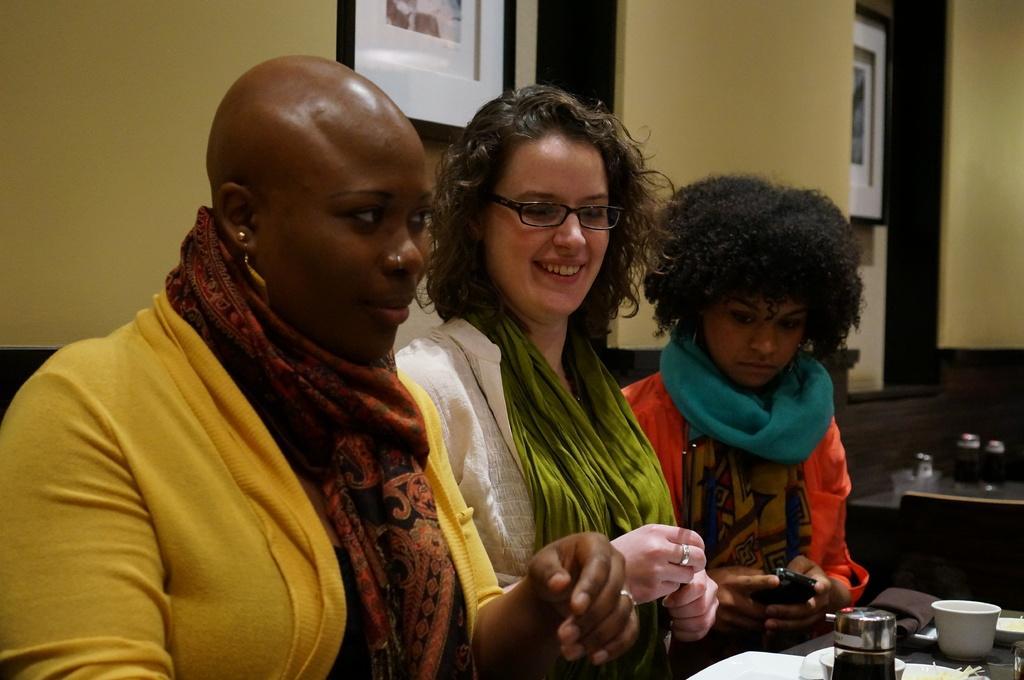In one or two sentences, can you explain what this image depicts? In this image, we can see three women are sitting side by side. In the middle of the image, a woman is smiling and holding chopsticks. Beside her another woman is holding a mobile. In the bottom right corner, there is a table. Few things, container and bowl are placed on it. In the background, we can see the wall and photo frames. On the right side of the image, we can see table and few objects. 